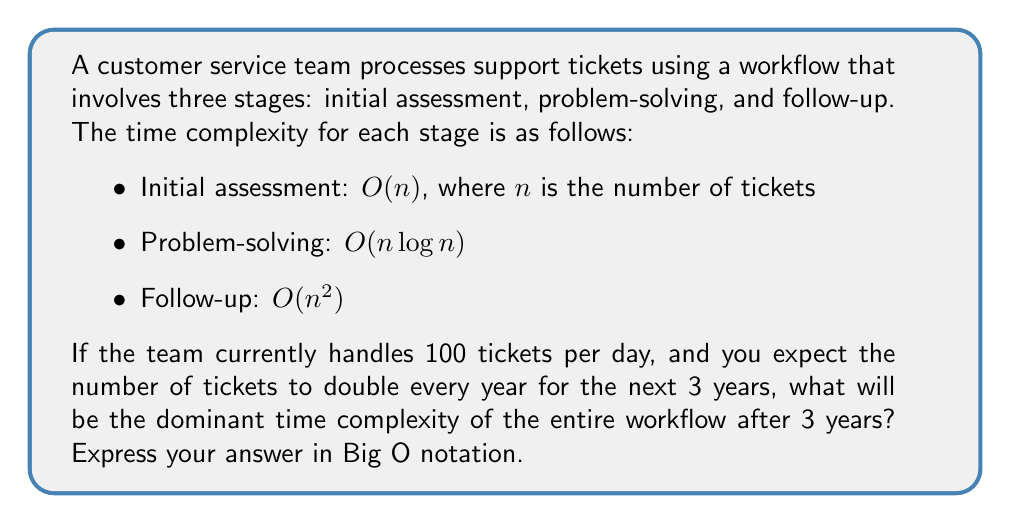Could you help me with this problem? To solve this problem, we need to follow these steps:

1. Calculate the number of tickets after 3 years:
   - Initial: 100 tickets
   - After 1 year: 200 tickets
   - After 2 years: 400 tickets
   - After 3 years: 800 tickets

2. Analyze the time complexity of each stage with 800 tickets:
   - Initial assessment: $O(800) = O(n)$
   - Problem-solving: $O(800 \log 800) = O(n \log n)$
   - Follow-up: $O(800^2) = O(n^2)$

3. Determine the dominant time complexity:
   The dominant time complexity is the one with the highest order of growth. In this case:
   
   $O(n) < O(n \log n) < O(n^2)$

   Therefore, the follow-up stage with $O(n^2)$ dominates the overall time complexity.

4. Express the answer in Big O notation:
   The dominant time complexity is $O(n^2)$.
Answer: $O(n^2)$ 